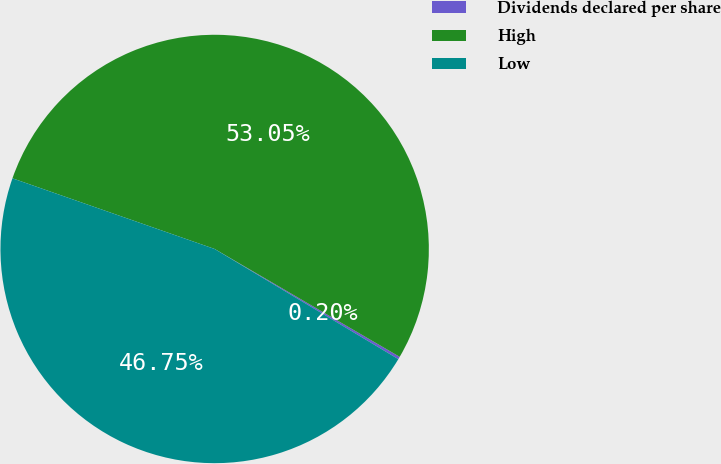Convert chart to OTSL. <chart><loc_0><loc_0><loc_500><loc_500><pie_chart><fcel>Dividends declared per share<fcel>High<fcel>Low<nl><fcel>0.2%<fcel>53.05%<fcel>46.75%<nl></chart> 